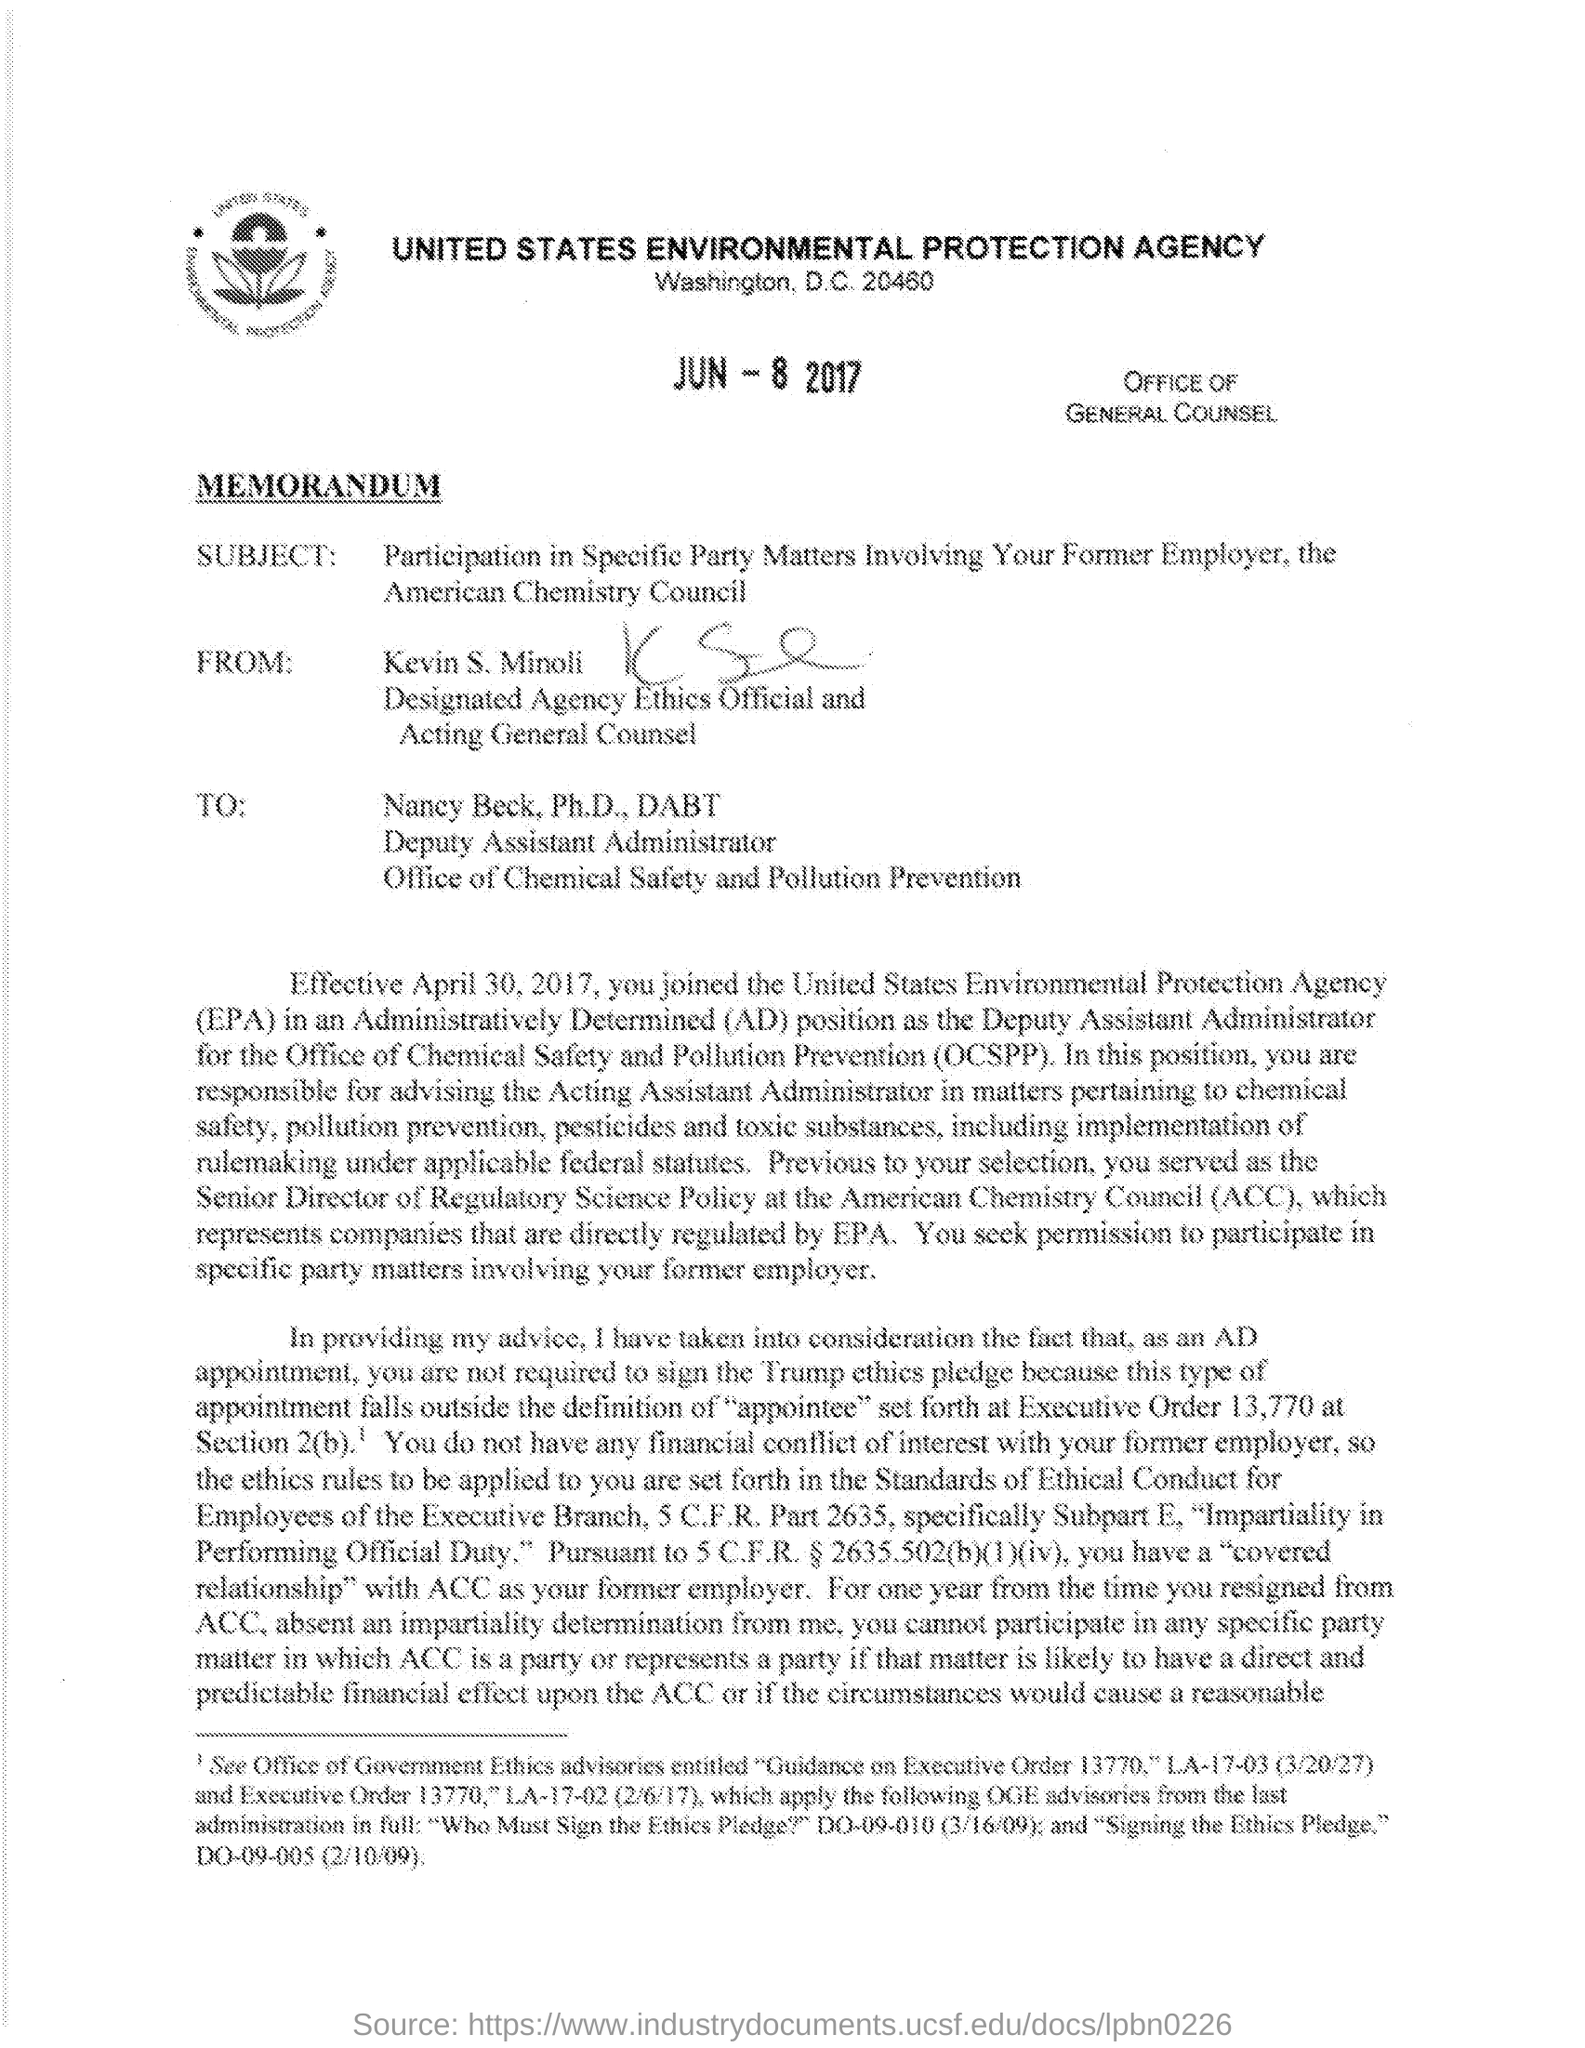Draw attention to some important aspects in this diagram. The person designated as the agency ethics official and acting general counsel is Kevin S. Minoli. The Office of Chemical Safety and Pollution Prevention (OCSPP) is a government organization that is responsible for regulating the use and disposal of chemicals to prevent pollution and ensure the safety of the public and the environment. The United States Environmental Protection Agency (EPA) is located in Washington, D.C. The subject of the memorandum is my participation in specific party matters involving my former employer, the American Chemistry Council. 